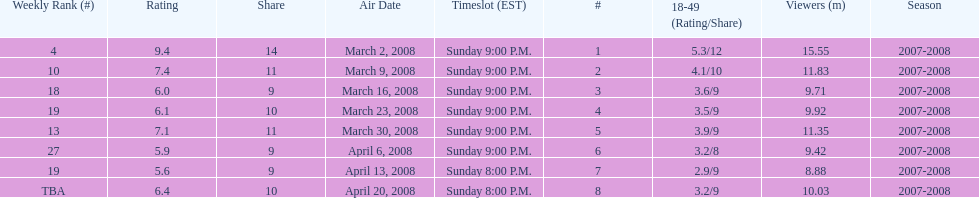How long did the program air for in days? 8. 